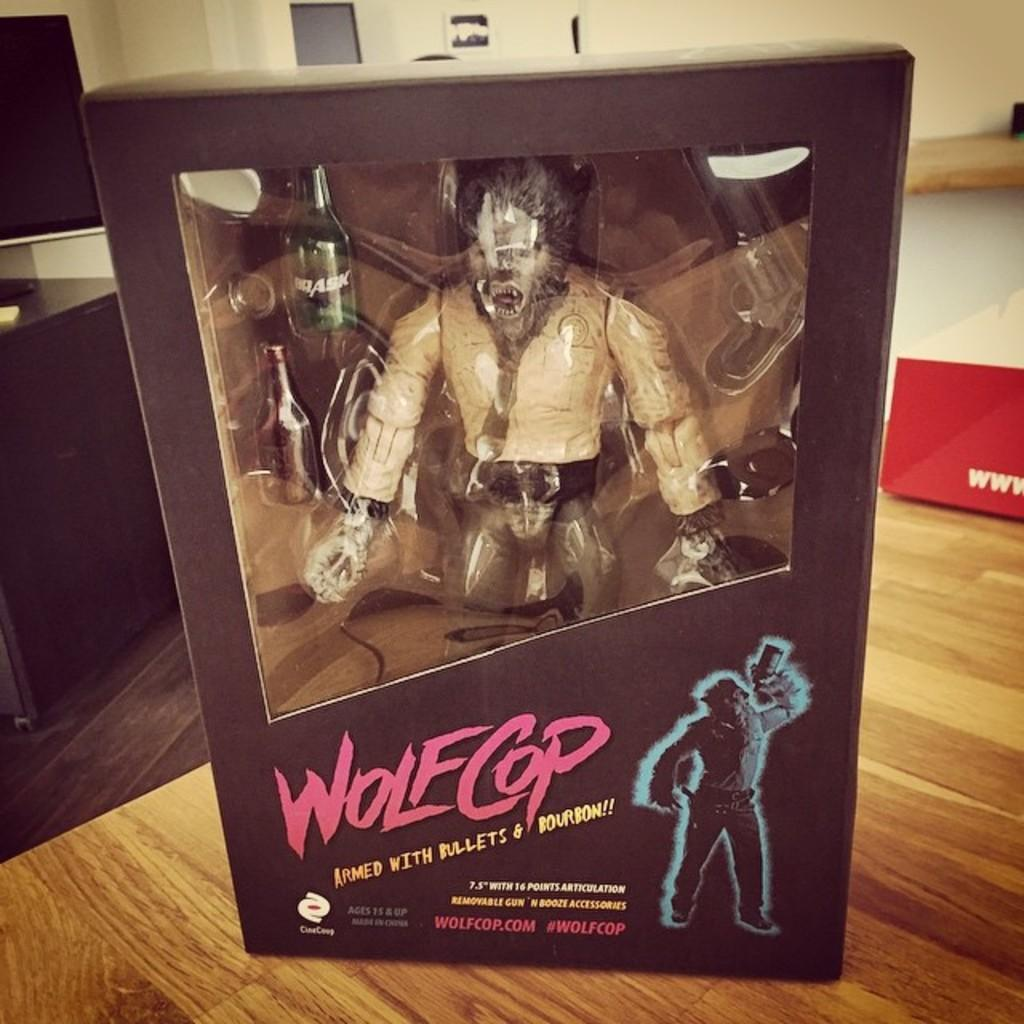<image>
Provide a brief description of the given image. A figuring toy of a character named WolfCop 